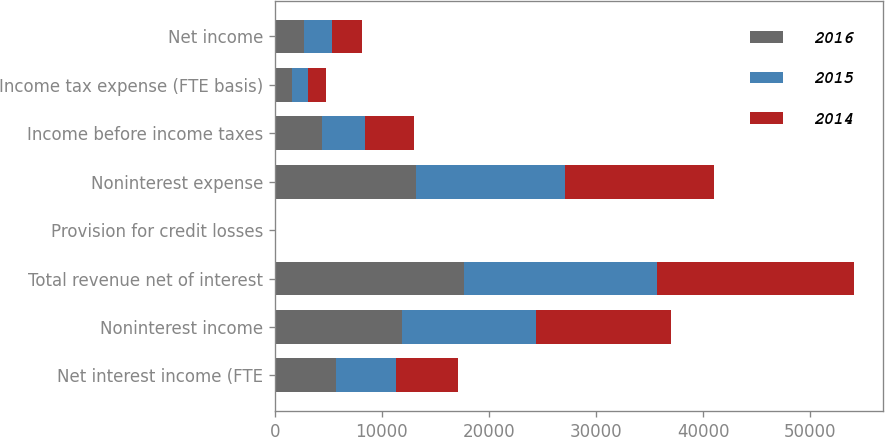<chart> <loc_0><loc_0><loc_500><loc_500><stacked_bar_chart><ecel><fcel>Net interest income (FTE<fcel>Noninterest income<fcel>Total revenue net of interest<fcel>Provision for credit losses<fcel>Noninterest expense<fcel>Income before income taxes<fcel>Income tax expense (FTE basis)<fcel>Net income<nl><fcel>2016<fcel>5759<fcel>11891<fcel>17650<fcel>68<fcel>13182<fcel>4400<fcel>1629<fcel>2771<nl><fcel>2015<fcel>5527<fcel>12507<fcel>18034<fcel>51<fcel>13943<fcel>4040<fcel>1473<fcel>2567<nl><fcel>2014<fcel>5830<fcel>12573<fcel>18403<fcel>14<fcel>13836<fcel>4553<fcel>1698<fcel>2855<nl></chart> 